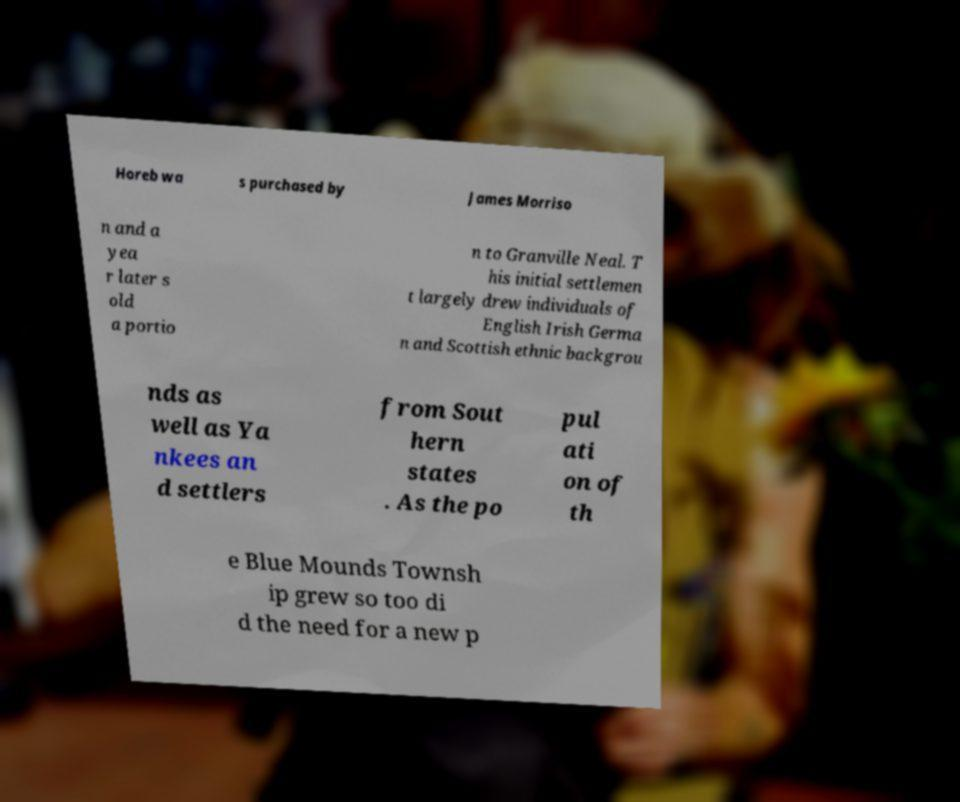Please read and relay the text visible in this image. What does it say? Horeb wa s purchased by James Morriso n and a yea r later s old a portio n to Granville Neal. T his initial settlemen t largely drew individuals of English Irish Germa n and Scottish ethnic backgrou nds as well as Ya nkees an d settlers from Sout hern states . As the po pul ati on of th e Blue Mounds Townsh ip grew so too di d the need for a new p 